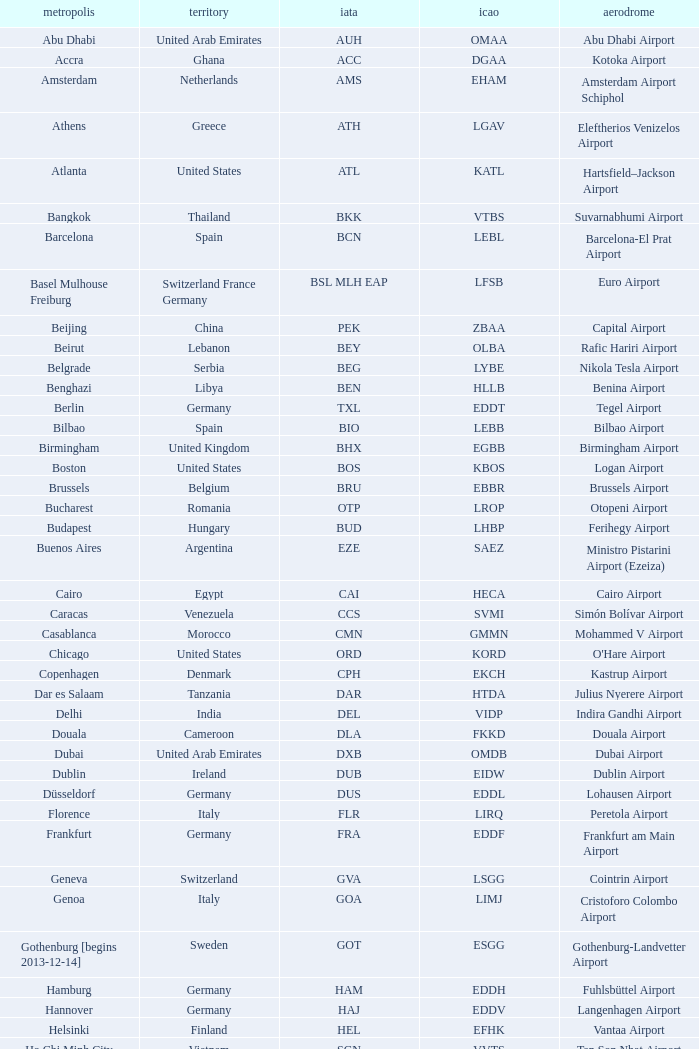What city is fuhlsbüttel airport in? Hamburg. 